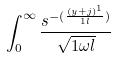Convert formula to latex. <formula><loc_0><loc_0><loc_500><loc_500>\int _ { 0 } ^ { \infty } \frac { s ^ { - ( \frac { ( y + j ) ^ { 1 } } { 1 l } ) } } { \sqrt { 1 \omega l } }</formula> 